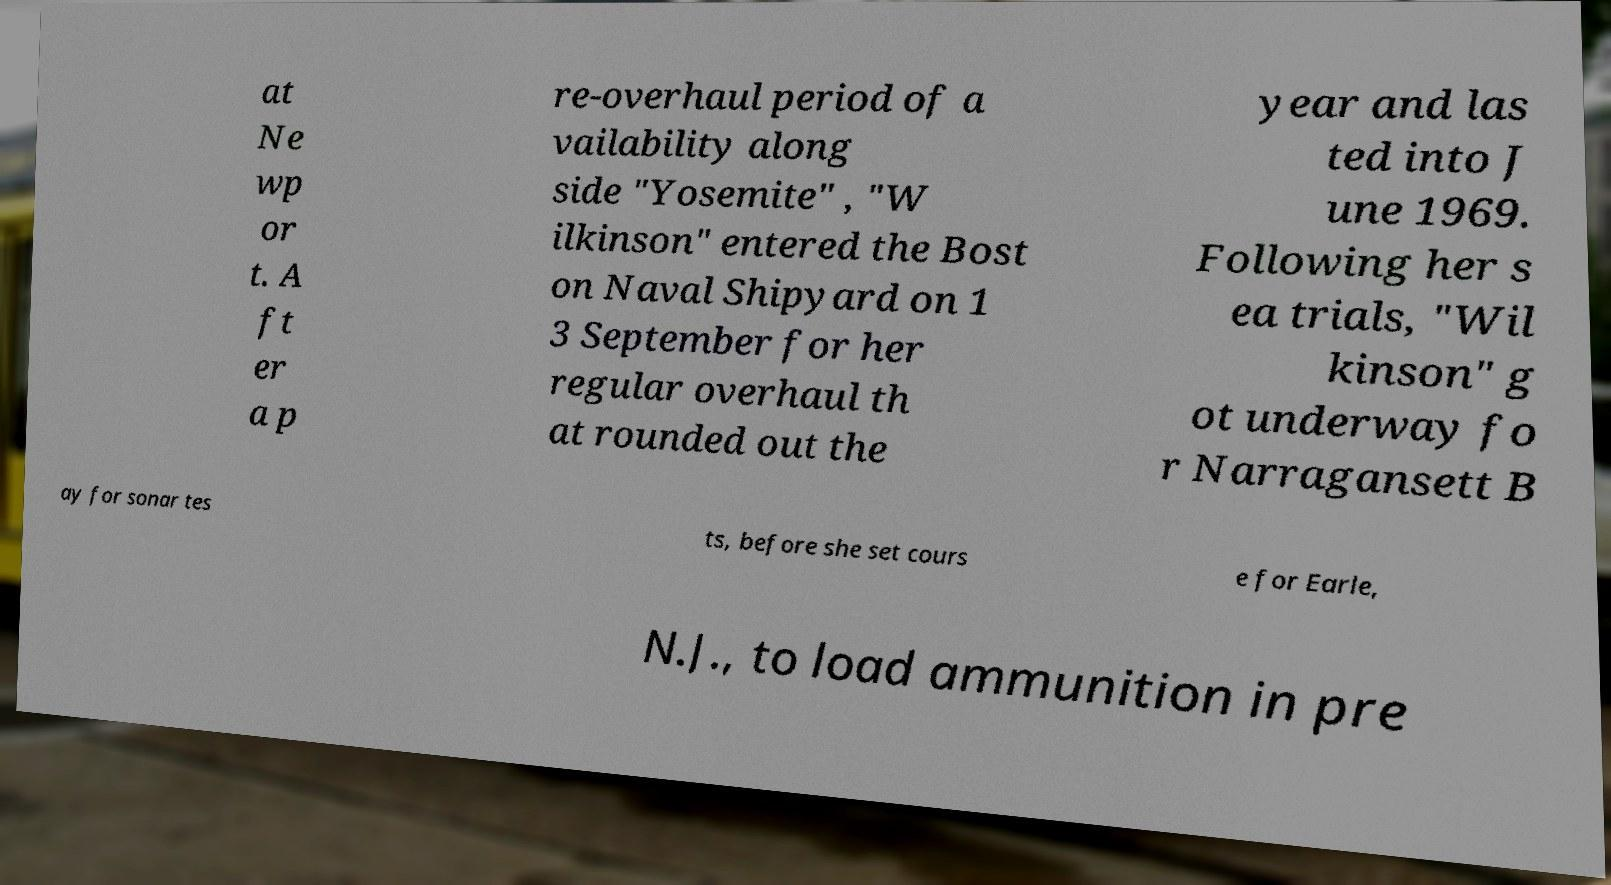There's text embedded in this image that I need extracted. Can you transcribe it verbatim? at Ne wp or t. A ft er a p re-overhaul period of a vailability along side "Yosemite" , "W ilkinson" entered the Bost on Naval Shipyard on 1 3 September for her regular overhaul th at rounded out the year and las ted into J une 1969. Following her s ea trials, "Wil kinson" g ot underway fo r Narragansett B ay for sonar tes ts, before she set cours e for Earle, N.J., to load ammunition in pre 